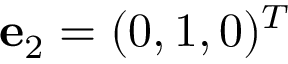<formula> <loc_0><loc_0><loc_500><loc_500>{ e } _ { 2 } = ( 0 , 1 , 0 ) ^ { T }</formula> 